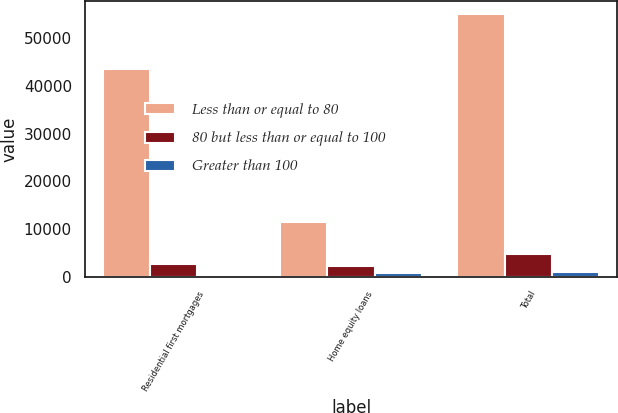Convert chart to OTSL. <chart><loc_0><loc_0><loc_500><loc_500><stacked_bar_chart><ecel><fcel>Residential first mortgages<fcel>Home equity loans<fcel>Total<nl><fcel>Less than or equal to 80<fcel>43626<fcel>11403<fcel>55029<nl><fcel>80 but less than or equal to 100<fcel>2578<fcel>2147<fcel>4725<nl><fcel>Greater than 100<fcel>247<fcel>800<fcel>1047<nl></chart> 